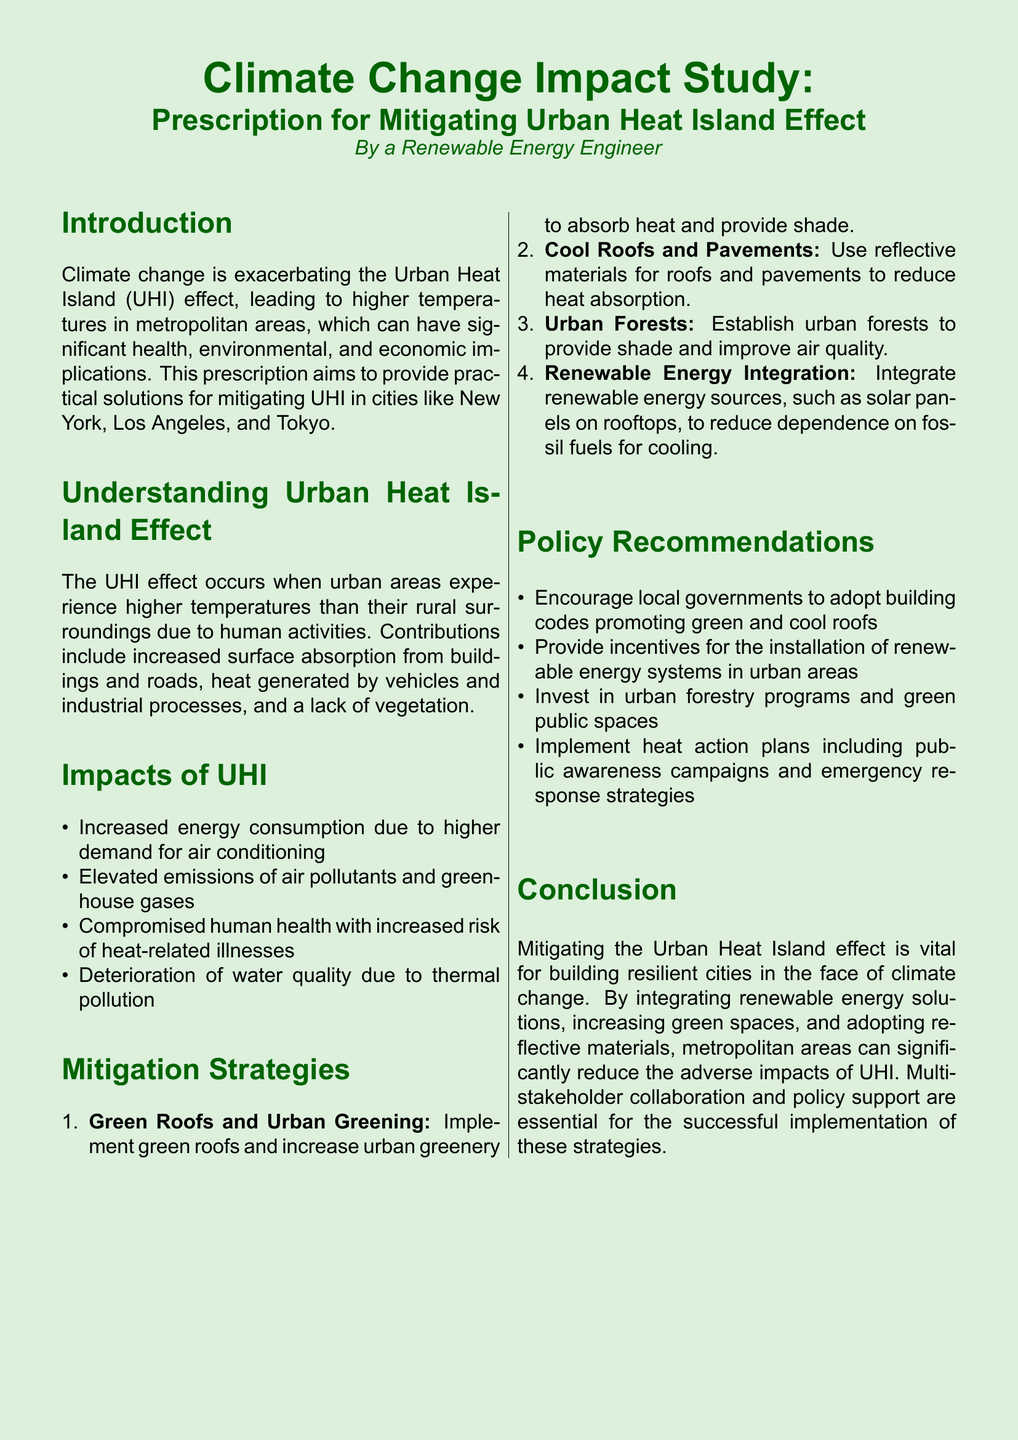What is the title of the document? The title is clearly stated at the top of the document.
Answer: Prescription for Mitigating Urban Heat Island Effect in Metropolitan Areas What cities are mentioned as examples for mitigating UHI? The document lists specific metropolitan areas as examples for context.
Answer: New York, Los Angeles, and Tokyo What color is the page background? The document specifies the background color at the beginning.
Answer: Light green How many mitigation strategies are provided? The strategies are enumerated within the document.
Answer: Four What health risk is associated with UHI? The impacts of UHI include various health risks mentioned in the document.
Answer: Heat-related illnesses What is a suggested policy recommendation for local governments? The document provides policy recommendations that are clear and actionable.
Answer: Adopt building codes promoting green and cool roofs Which type of roofs can help mitigate UHI? Several strategies are listed with specific types of roofs mentioned.
Answer: Green roofs What kind of energy sources should be integrated according to the document? The document specifies the type of energy sources recommended in the mitigation strategies.
Answer: Renewable energy sources 